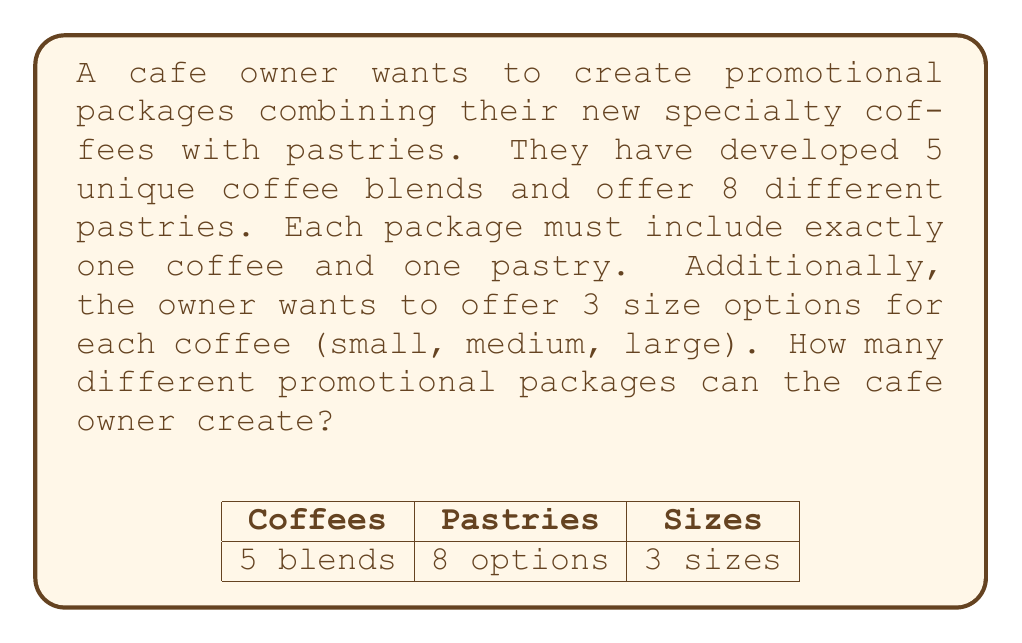Can you solve this math problem? Let's break this down step-by-step:

1) First, we need to consider the number of coffee options:
   - There are 5 unique coffee blends
   - Each blend comes in 3 sizes
   - So, the total number of coffee options is: $5 \times 3 = 15$

2) Now, for the pastries:
   - There are 8 different pastries to choose from

3) To create a package, we need to choose:
   - One coffee option (out of 15)
   - One pastry (out of 8)

4) This is a combination problem where we're selecting one item from each category. In such cases, we multiply the number of options for each category:

   $$\text{Total packages} = \text{Coffee options} \times \text{Pastry options}$$
   $$\text{Total packages} = 15 \times 8$$

5) Calculating the final result:
   $$\text{Total packages} = 15 \times 8 = 120$$

Therefore, the cafe owner can create 120 different promotional packages.
Answer: 120 packages 